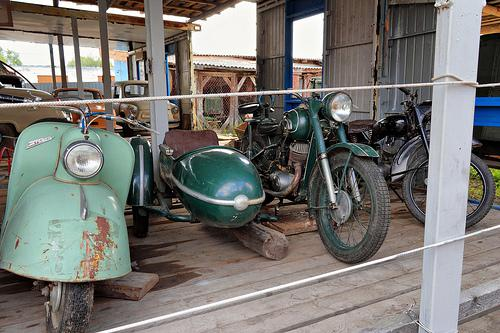Question: who is standing behind the motorbikes?
Choices:
A. The mechanic.
B. No one.
C. The riders.
D. The traffic cop.
Answer with the letter. Answer: B Question: what type of vehicle is shown in this photo?
Choices:
A. Motorbikes.
B. Bus.
C. Train.
D. Automobile.
Answer with the letter. Answer: A Question: where was this photo taken?
Choices:
A. At a library.
B. At a museum.
C. At a home.
D. At a zoo.
Answer with the letter. Answer: B 